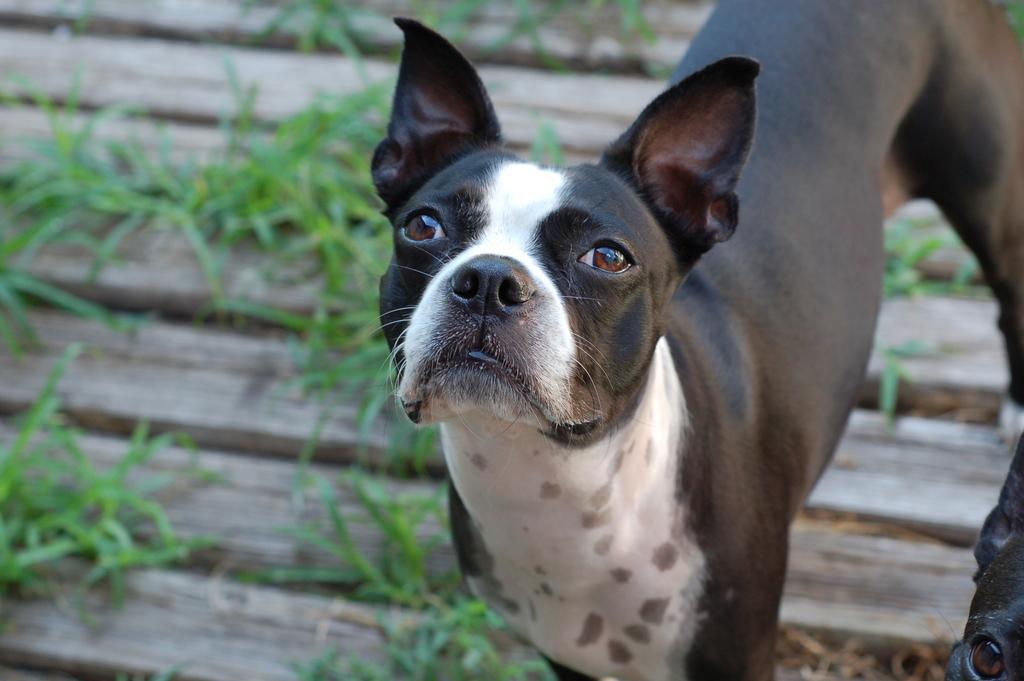Please provide a concise description of this image. As we can see in the image there is a black color dog and grass. 